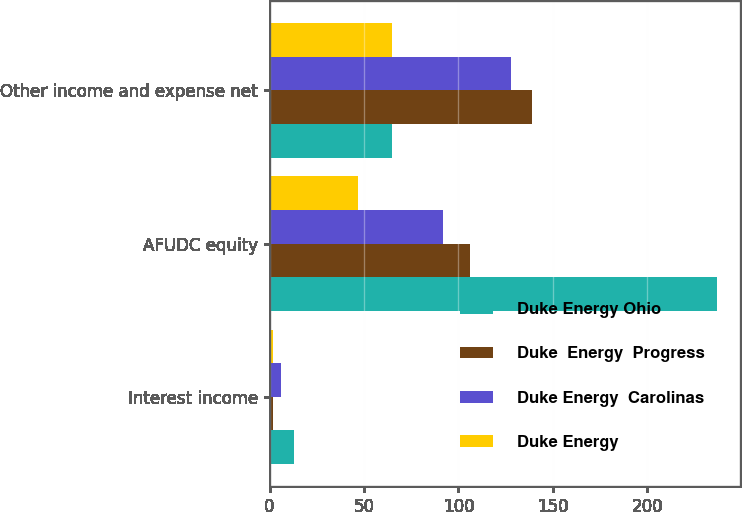Convert chart. <chart><loc_0><loc_0><loc_500><loc_500><stacked_bar_chart><ecel><fcel>Interest income<fcel>AFUDC equity<fcel>Other income and expense net<nl><fcel>Duke Energy Ohio<fcel>13<fcel>237<fcel>65<nl><fcel>Duke  Energy  Progress<fcel>2<fcel>106<fcel>139<nl><fcel>Duke Energy  Carolinas<fcel>6<fcel>92<fcel>128<nl><fcel>Duke Energy<fcel>2<fcel>47<fcel>65<nl></chart> 